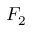Convert formula to latex. <formula><loc_0><loc_0><loc_500><loc_500>F _ { 2 }</formula> 